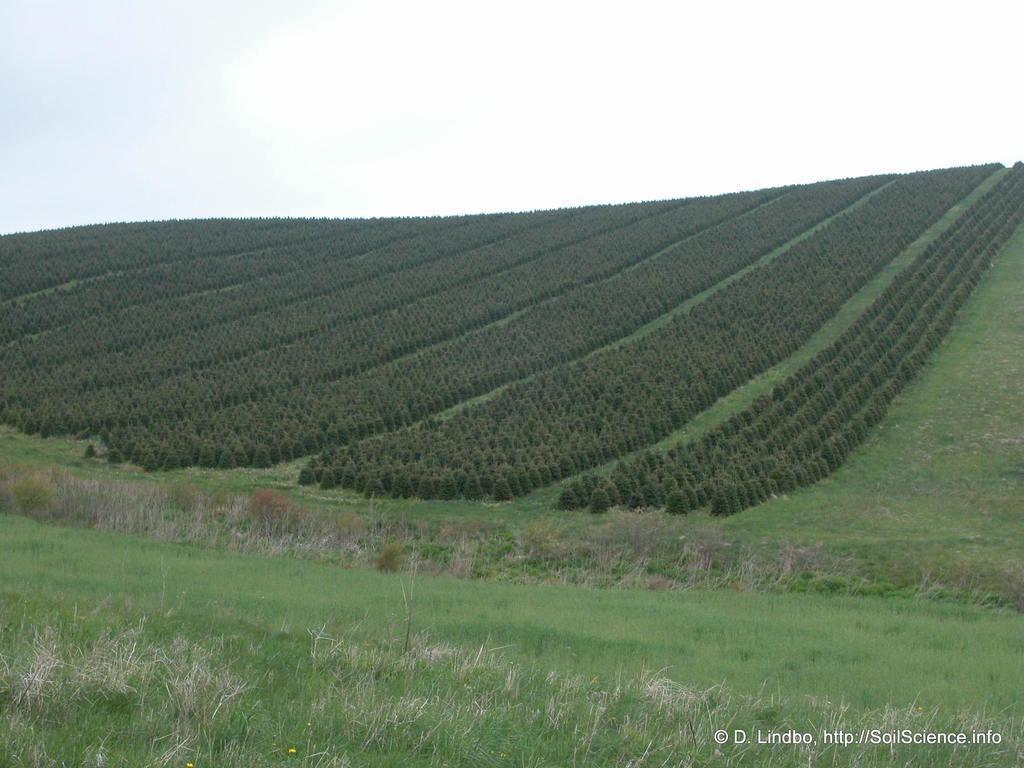Describe this image in one or two sentences. In the image we can see everywhere there is grass, plants and white sky. At the right bottom we can see watermark. 